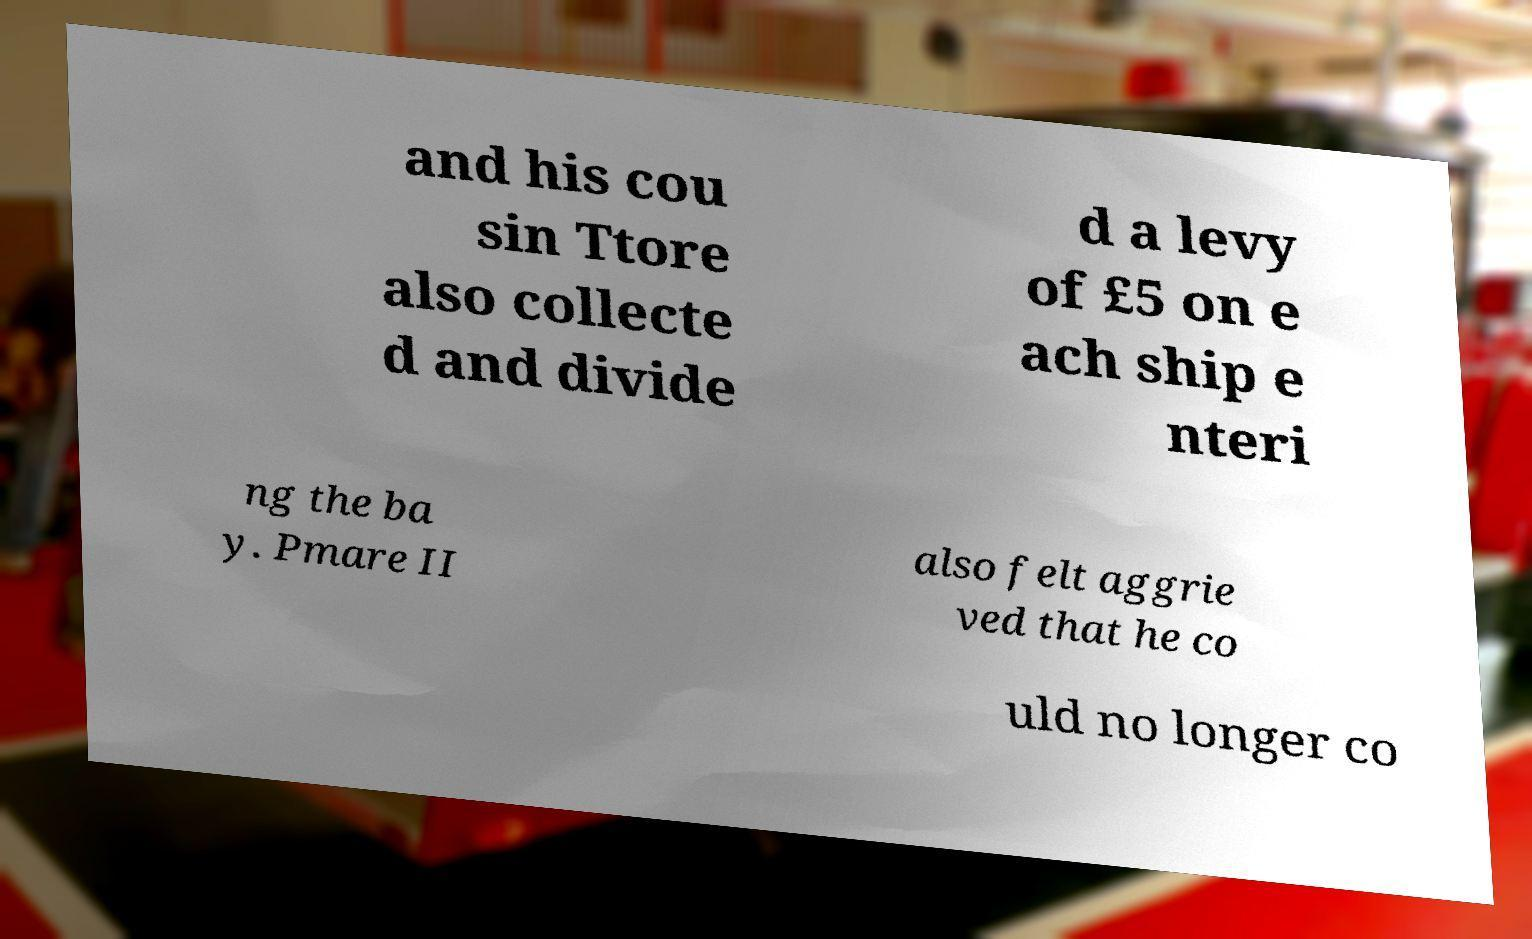Could you extract and type out the text from this image? and his cou sin Ttore also collecte d and divide d a levy of £5 on e ach ship e nteri ng the ba y. Pmare II also felt aggrie ved that he co uld no longer co 